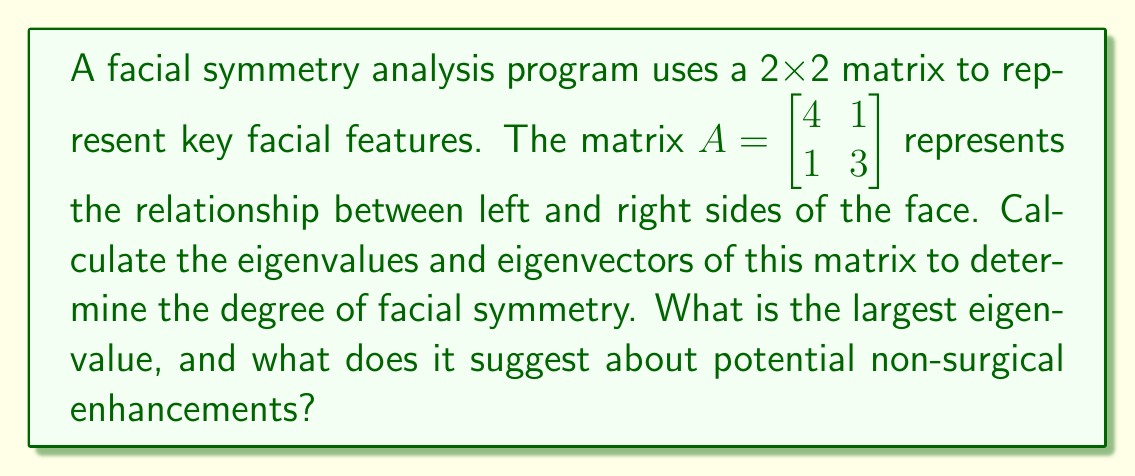Teach me how to tackle this problem. To find the eigenvalues and eigenvectors of matrix $A$:

1) Find the eigenvalues by solving the characteristic equation:
   $det(A - \lambda I) = 0$
   
   $\begin{vmatrix} 4-\lambda & 1 \\ 1 & 3-\lambda \end{vmatrix} = 0$
   
   $(4-\lambda)(3-\lambda) - 1 = 0$
   
   $\lambda^2 - 7\lambda + 11 = 0$

2) Solve the quadratic equation:
   $\lambda = \frac{7 \pm \sqrt{49 - 44}}{2} = \frac{7 \pm \sqrt{5}}{2}$

   $\lambda_1 = \frac{7 + \sqrt{5}}{2} \approx 4.618$ (larger eigenvalue)
   $\lambda_2 = \frac{7 - \sqrt{5}}{2} \approx 2.382$

3) Find the eigenvectors for $\lambda_1$:
   $(A - \lambda_1 I)v = 0$
   
   $\begin{bmatrix} 4-\lambda_1 & 1 \\ 1 & 3-\lambda_1 \end{bmatrix} \begin{bmatrix} v_1 \\ v_2 \end{bmatrix} = \begin{bmatrix} 0 \\ 0 \end{bmatrix}$
   
   Solving this system gives the eigenvector $v_1 = \begin{bmatrix} 1 \\ \frac{\sqrt{5}-1}{2} \end{bmatrix}$

The largest eigenvalue ($\lambda_1 \approx 4.618$) represents the direction of maximum stretch in the transformation. In the context of facial symmetry, a larger eigenvalue suggests a stronger correlation between facial features on both sides. This indicates good natural symmetry, implying that non-surgical enhancements like makeup contouring or hairstyling might be sufficient to achieve the desired aesthetic balance.
Answer: $\lambda_1 \approx 4.618$; suggests good natural symmetry, favoring non-surgical enhancements. 